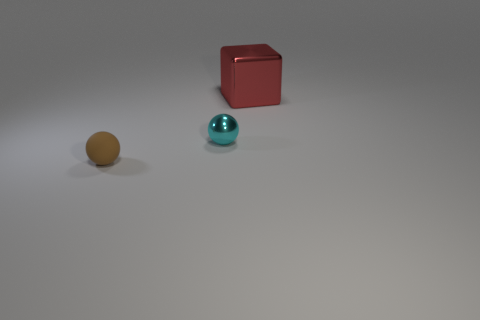Add 2 big brown metal blocks. How many objects exist? 5 Subtract all balls. How many objects are left? 1 Add 1 tiny brown matte objects. How many tiny brown matte objects are left? 2 Add 1 large red blocks. How many large red blocks exist? 2 Subtract 0 purple cylinders. How many objects are left? 3 Subtract all large cyan things. Subtract all tiny brown rubber things. How many objects are left? 2 